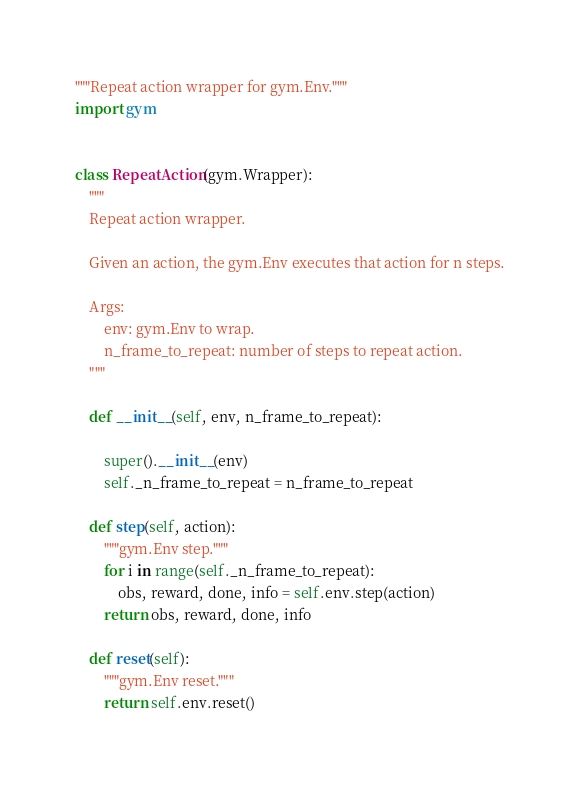Convert code to text. <code><loc_0><loc_0><loc_500><loc_500><_Python_>"""Repeat action wrapper for gym.Env."""
import gym


class RepeatAction(gym.Wrapper):
    """
    Repeat action wrapper.

    Given an action, the gym.Env executes that action for n steps.

    Args:
        env: gym.Env to wrap.
        n_frame_to_repeat: number of steps to repeat action.
    """

    def __init__(self, env, n_frame_to_repeat):

        super().__init__(env)
        self._n_frame_to_repeat = n_frame_to_repeat

    def step(self, action):
        """gym.Env step."""
        for i in range(self._n_frame_to_repeat):
            obs, reward, done, info = self.env.step(action)
        return obs, reward, done, info

    def reset(self):
        """gym.Env reset."""
        return self.env.reset()
</code> 